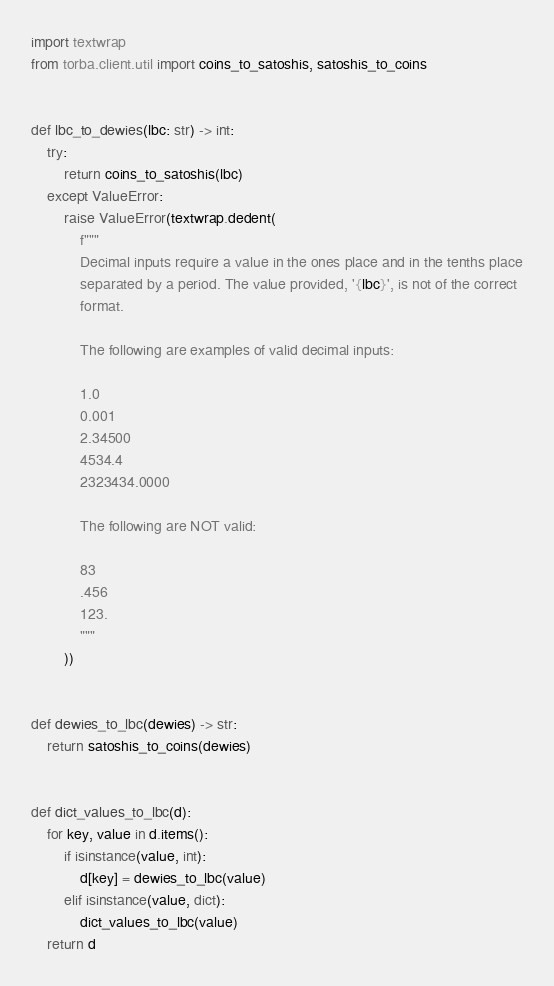Convert code to text. <code><loc_0><loc_0><loc_500><loc_500><_Python_>import textwrap
from torba.client.util import coins_to_satoshis, satoshis_to_coins


def lbc_to_dewies(lbc: str) -> int:
    try:
        return coins_to_satoshis(lbc)
    except ValueError:
        raise ValueError(textwrap.dedent(
            f"""
            Decimal inputs require a value in the ones place and in the tenths place
            separated by a period. The value provided, '{lbc}', is not of the correct
            format.

            The following are examples of valid decimal inputs:

            1.0
            0.001
            2.34500
            4534.4
            2323434.0000

            The following are NOT valid:

            83
            .456
            123.
            """
        ))


def dewies_to_lbc(dewies) -> str:
    return satoshis_to_coins(dewies)


def dict_values_to_lbc(d):
    for key, value in d.items():
        if isinstance(value, int):
            d[key] = dewies_to_lbc(value)
        elif isinstance(value, dict):
            dict_values_to_lbc(value)
    return d
</code> 